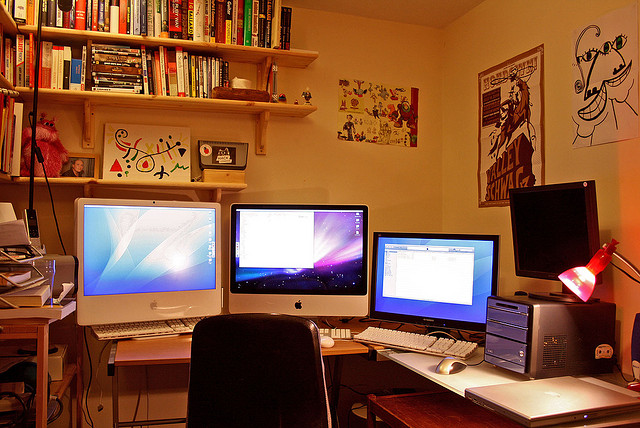Extract all visible text content from this image. VALLEY 